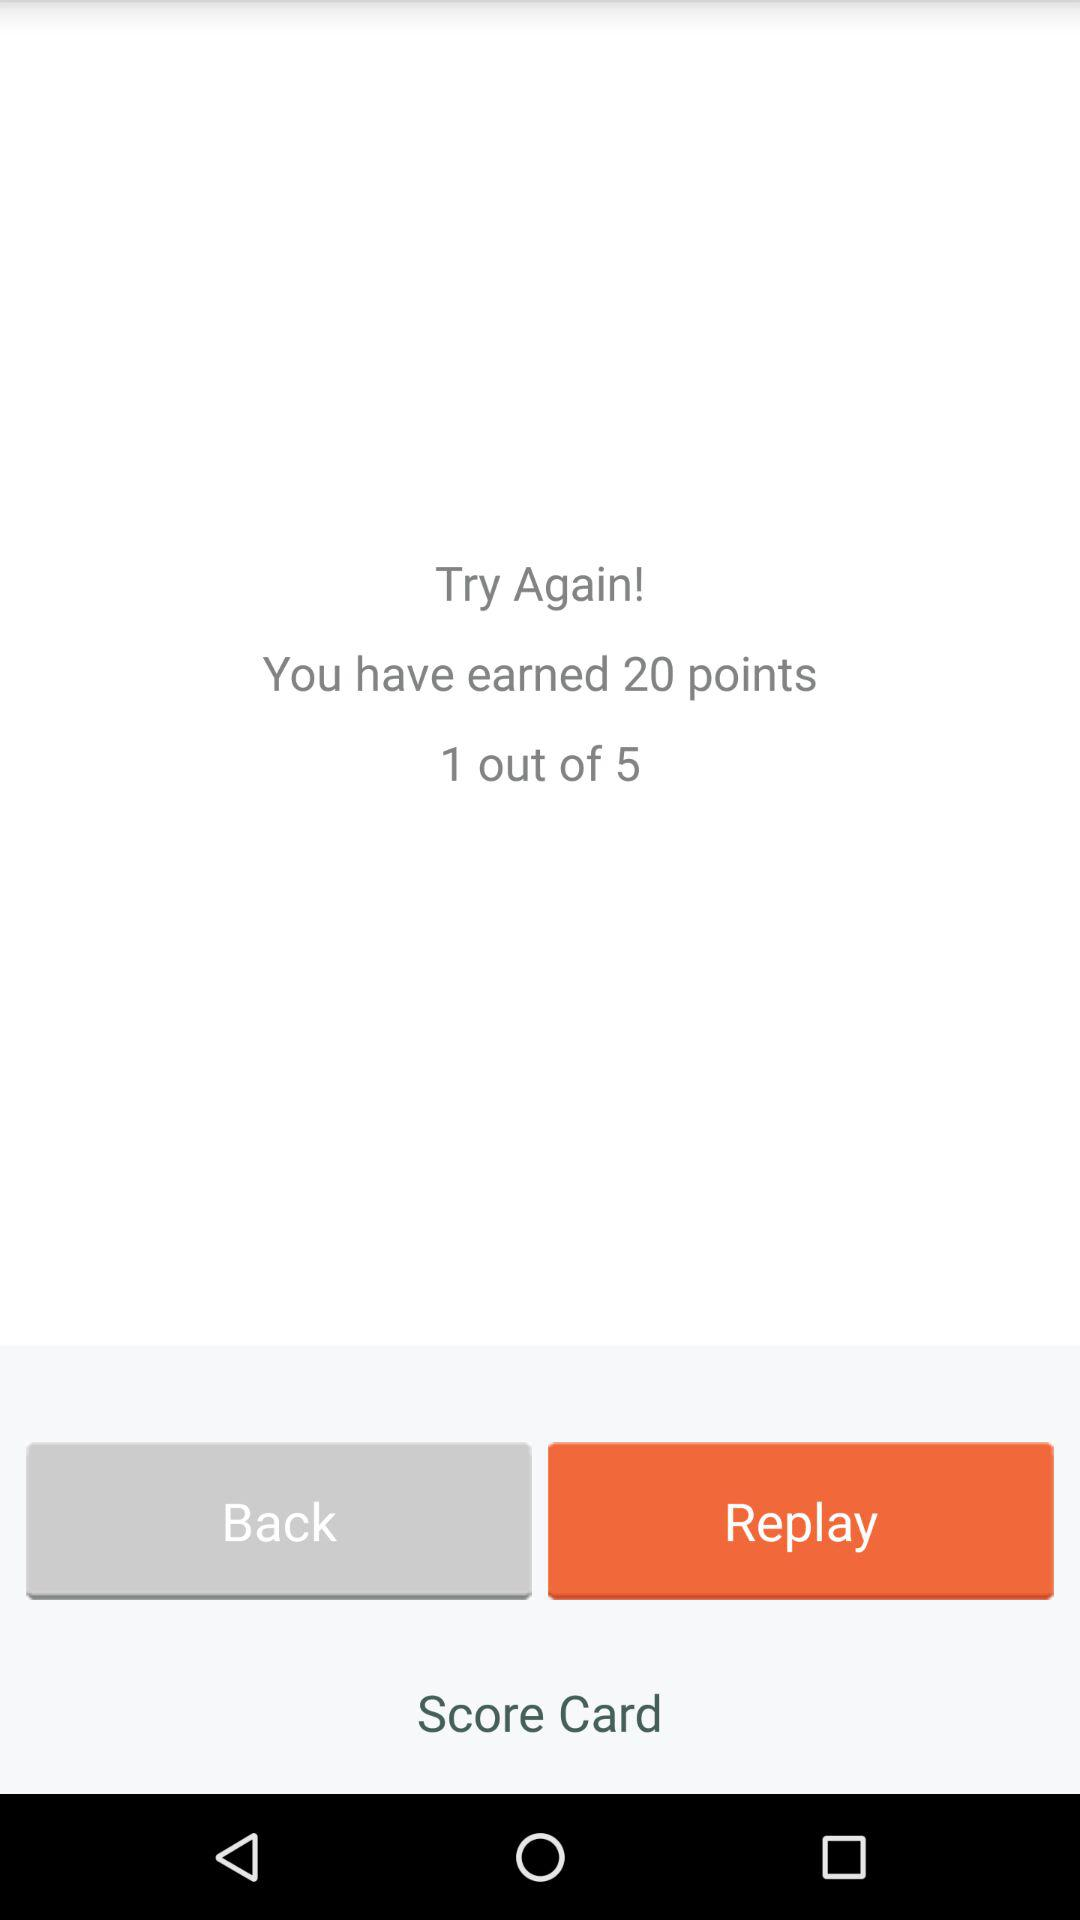What is the maximum attempt limit? The maximum attempt limit is 5. 